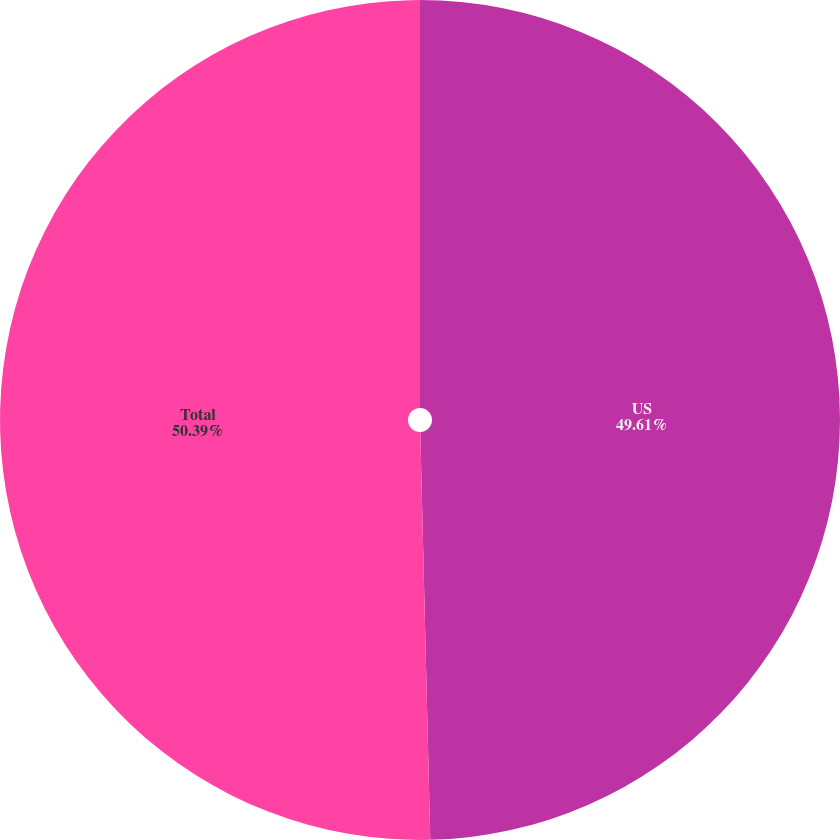<chart> <loc_0><loc_0><loc_500><loc_500><pie_chart><fcel>US<fcel>Total<nl><fcel>49.61%<fcel>50.39%<nl></chart> 